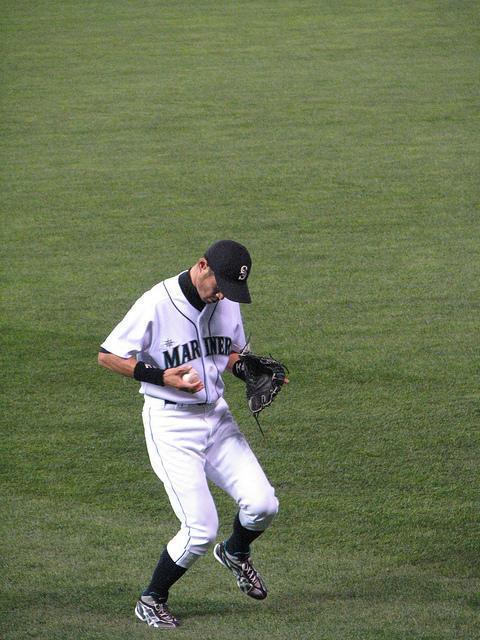Why is the man wearing a glove?
Indicate the correct response by choosing from the four available options to answer the question.
Options: Warmth, to catch, fashion, health. To catch. 